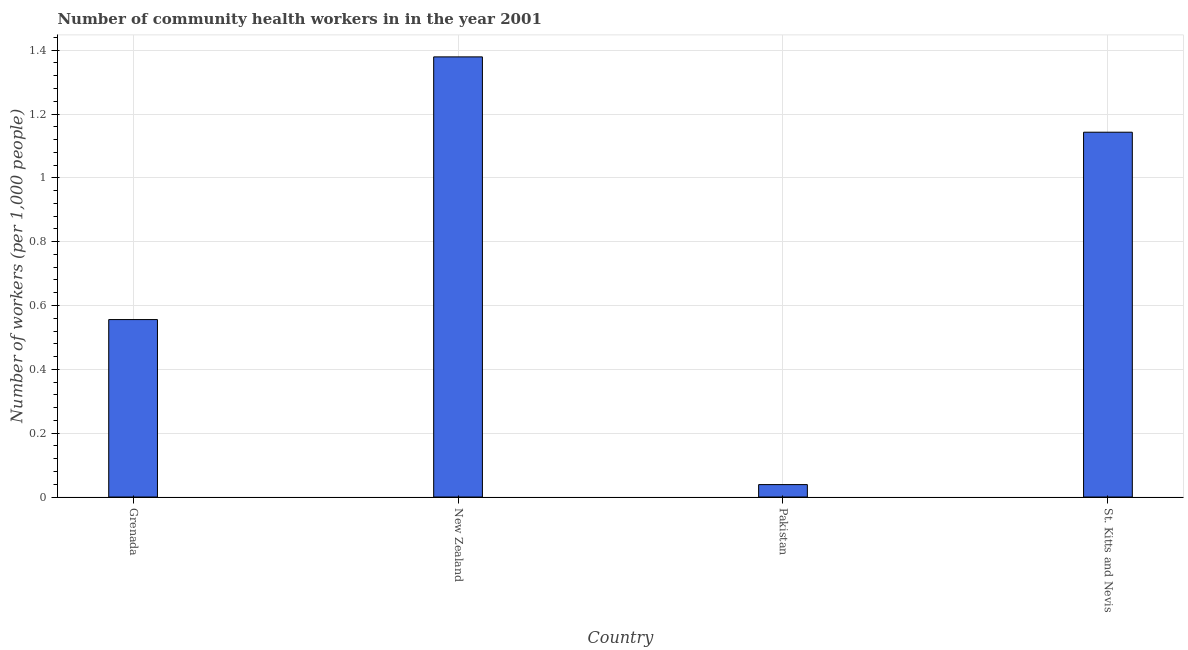Does the graph contain grids?
Your answer should be compact. Yes. What is the title of the graph?
Offer a very short reply. Number of community health workers in in the year 2001. What is the label or title of the X-axis?
Offer a very short reply. Country. What is the label or title of the Y-axis?
Offer a terse response. Number of workers (per 1,0 people). What is the number of community health workers in New Zealand?
Offer a terse response. 1.38. Across all countries, what is the maximum number of community health workers?
Make the answer very short. 1.38. Across all countries, what is the minimum number of community health workers?
Ensure brevity in your answer.  0.04. In which country was the number of community health workers maximum?
Offer a very short reply. New Zealand. In which country was the number of community health workers minimum?
Make the answer very short. Pakistan. What is the sum of the number of community health workers?
Your answer should be compact. 3.12. What is the difference between the number of community health workers in New Zealand and St. Kitts and Nevis?
Make the answer very short. 0.24. What is the average number of community health workers per country?
Keep it short and to the point. 0.78. What is the median number of community health workers?
Your response must be concise. 0.85. What is the ratio of the number of community health workers in Grenada to that in New Zealand?
Your answer should be compact. 0.4. Is the difference between the number of community health workers in Grenada and St. Kitts and Nevis greater than the difference between any two countries?
Provide a succinct answer. No. What is the difference between the highest and the second highest number of community health workers?
Make the answer very short. 0.24. What is the difference between the highest and the lowest number of community health workers?
Ensure brevity in your answer.  1.34. How many countries are there in the graph?
Your answer should be compact. 4. What is the Number of workers (per 1,000 people) in Grenada?
Provide a short and direct response. 0.56. What is the Number of workers (per 1,000 people) of New Zealand?
Make the answer very short. 1.38. What is the Number of workers (per 1,000 people) of Pakistan?
Offer a terse response. 0.04. What is the Number of workers (per 1,000 people) in St. Kitts and Nevis?
Provide a succinct answer. 1.14. What is the difference between the Number of workers (per 1,000 people) in Grenada and New Zealand?
Your answer should be very brief. -0.82. What is the difference between the Number of workers (per 1,000 people) in Grenada and Pakistan?
Offer a very short reply. 0.52. What is the difference between the Number of workers (per 1,000 people) in Grenada and St. Kitts and Nevis?
Offer a terse response. -0.59. What is the difference between the Number of workers (per 1,000 people) in New Zealand and Pakistan?
Your answer should be very brief. 1.34. What is the difference between the Number of workers (per 1,000 people) in New Zealand and St. Kitts and Nevis?
Offer a very short reply. 0.24. What is the difference between the Number of workers (per 1,000 people) in Pakistan and St. Kitts and Nevis?
Offer a very short reply. -1.1. What is the ratio of the Number of workers (per 1,000 people) in Grenada to that in New Zealand?
Provide a short and direct response. 0.4. What is the ratio of the Number of workers (per 1,000 people) in Grenada to that in Pakistan?
Your answer should be very brief. 14.26. What is the ratio of the Number of workers (per 1,000 people) in Grenada to that in St. Kitts and Nevis?
Offer a terse response. 0.49. What is the ratio of the Number of workers (per 1,000 people) in New Zealand to that in Pakistan?
Your answer should be very brief. 35.36. What is the ratio of the Number of workers (per 1,000 people) in New Zealand to that in St. Kitts and Nevis?
Make the answer very short. 1.21. What is the ratio of the Number of workers (per 1,000 people) in Pakistan to that in St. Kitts and Nevis?
Keep it short and to the point. 0.03. 